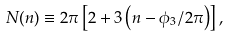Convert formula to latex. <formula><loc_0><loc_0><loc_500><loc_500>N ( n ) \equiv 2 \pi \left [ 2 + 3 \left ( n - \phi _ { 3 } / { 2 \pi } \right ) \right ] ,</formula> 